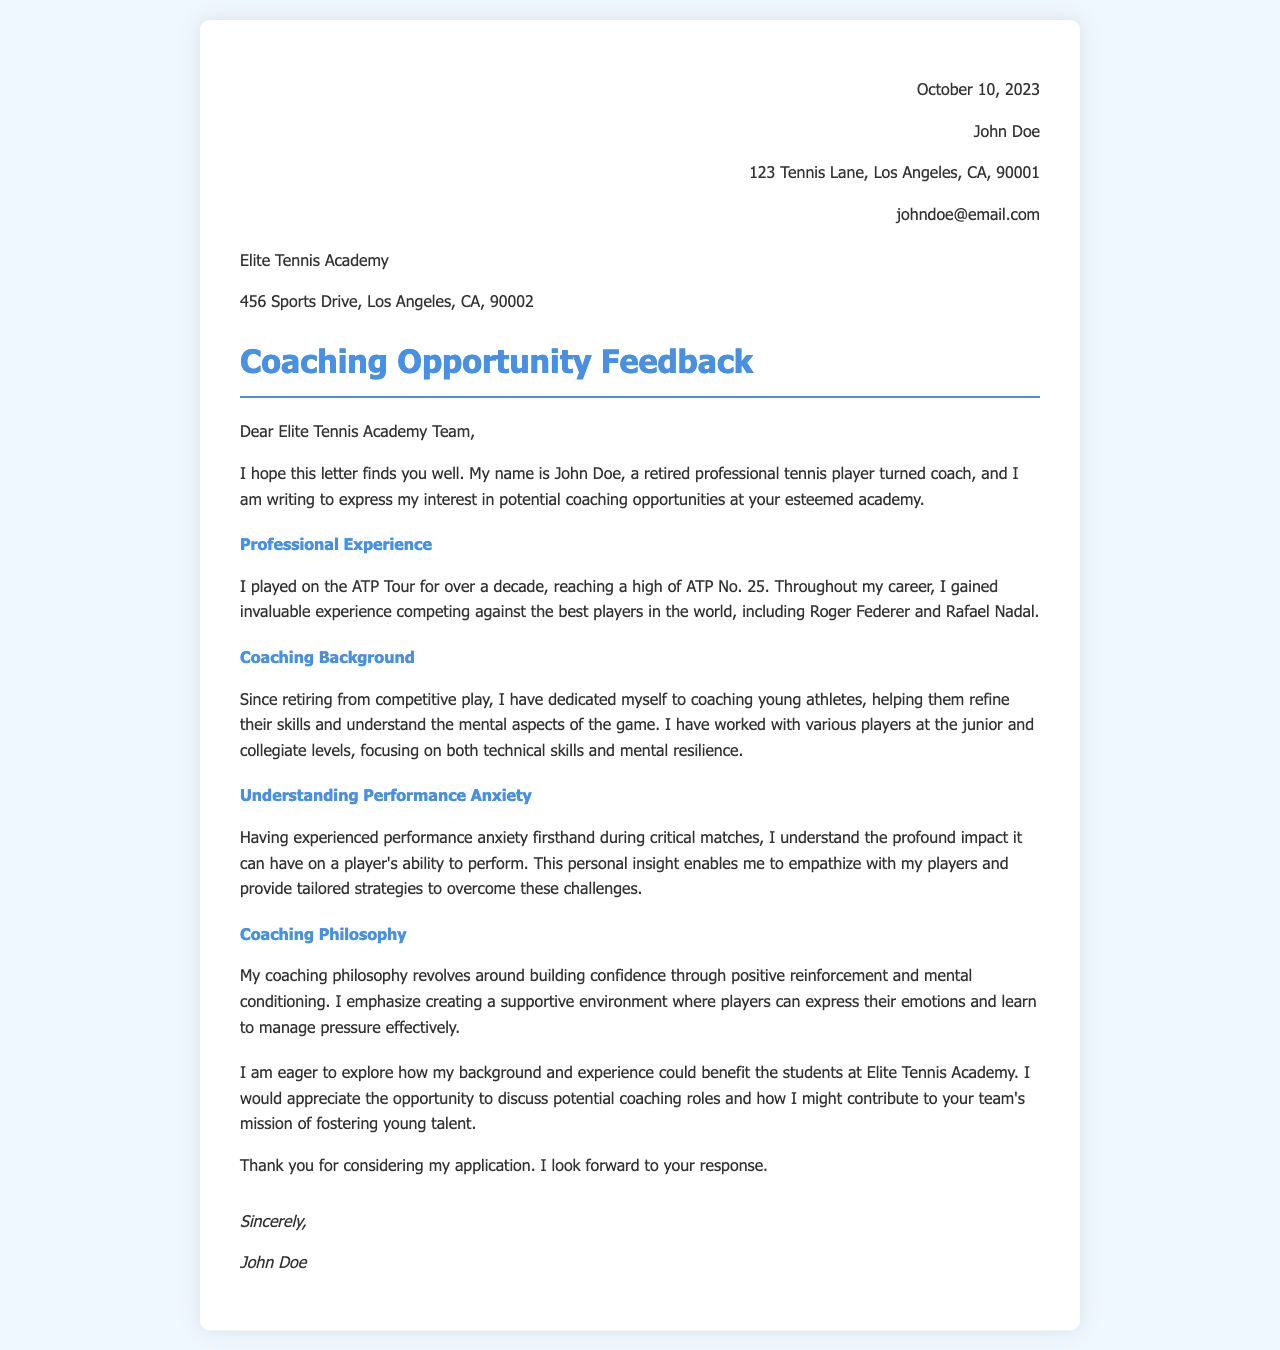What is the date of the letter? The letter is dated October 10, 2023, as indicated in the header.
Answer: October 10, 2023 Who is the author of the letter? The author of the letter is John Doe, mentioned at the top of the document.
Answer: John Doe What is the highest ATP ranking achieved by the author? The document states that the author reached a high of ATP No. 25 during his career.
Answer: ATP No. 25 Which academy is addressed in the letter? The letter is addressed to Elite Tennis Academy, mentioned in the academy address section.
Answer: Elite Tennis Academy What is the author's focus in coaching? The author mentions focusing on both technical skills and mental resilience in coaching young athletes.
Answer: Technical skills and mental resilience What personal experience does the author relate to coaching? The author shares his experience of having performance anxiety during critical matches, which informs his coaching strategy.
Answer: Performance anxiety What does the author hope to discuss with the academy? The author hopes to explore potential coaching roles and contributions to the academy's mission.
Answer: Potential coaching roles What is a key element of the author’s coaching philosophy? The author emphasizes building confidence through positive reinforcement.
Answer: Building confidence through positive reinforcement 